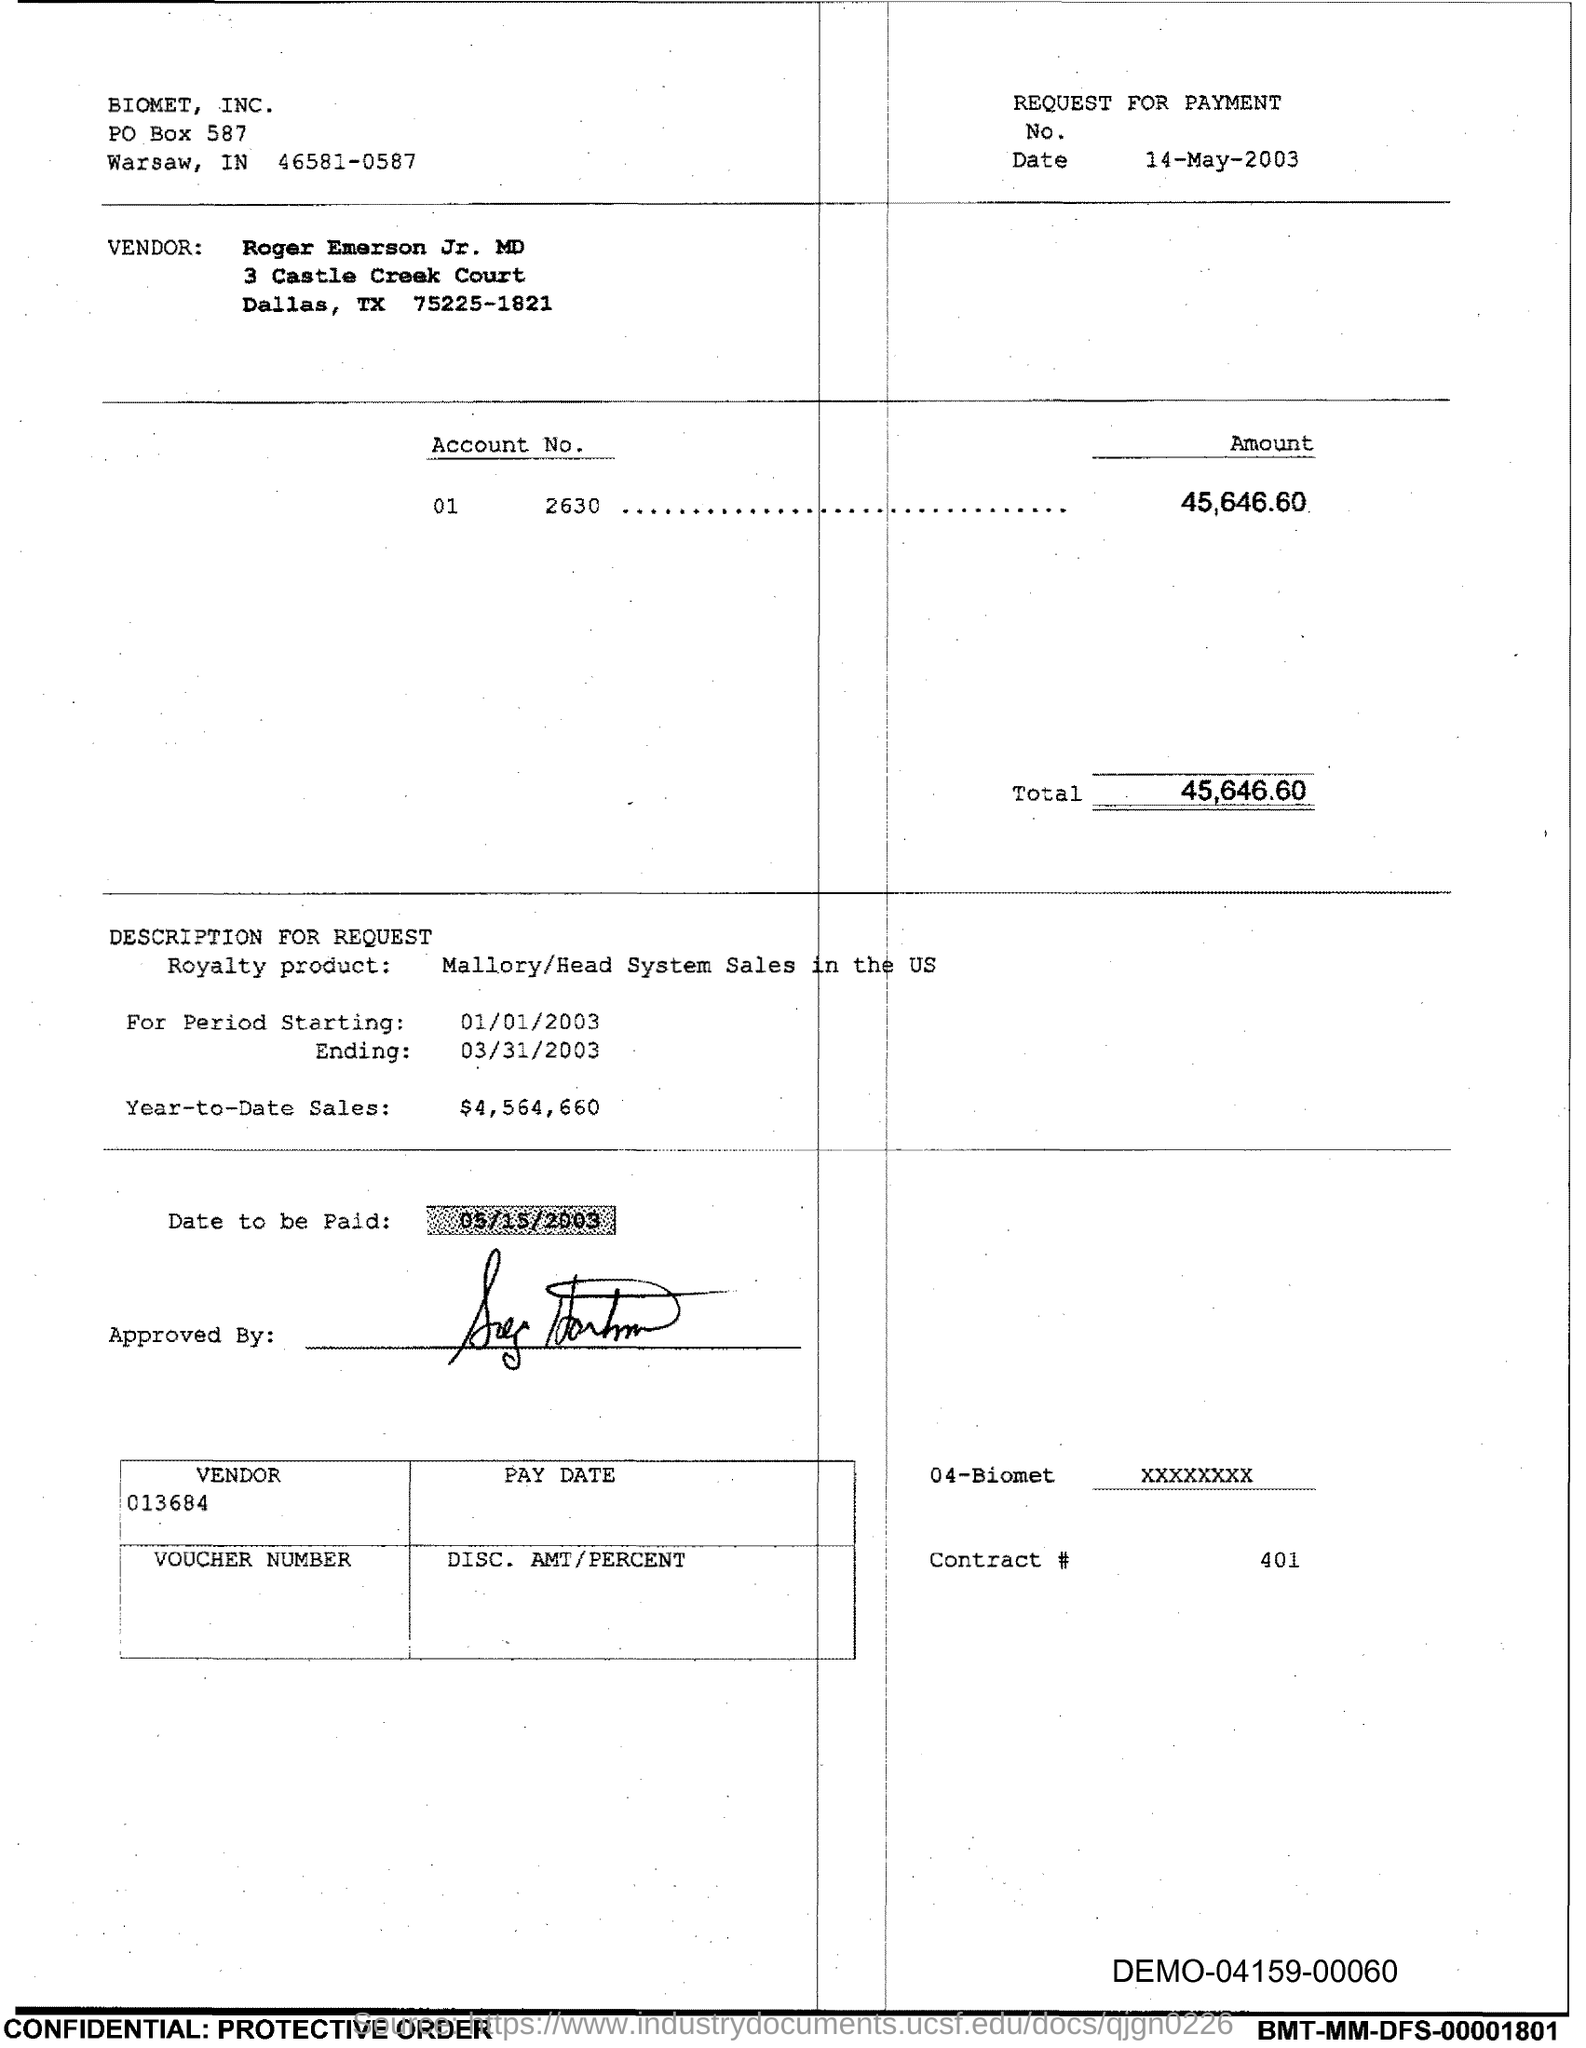What is the Total?
Give a very brief answer. 45,646.60. 